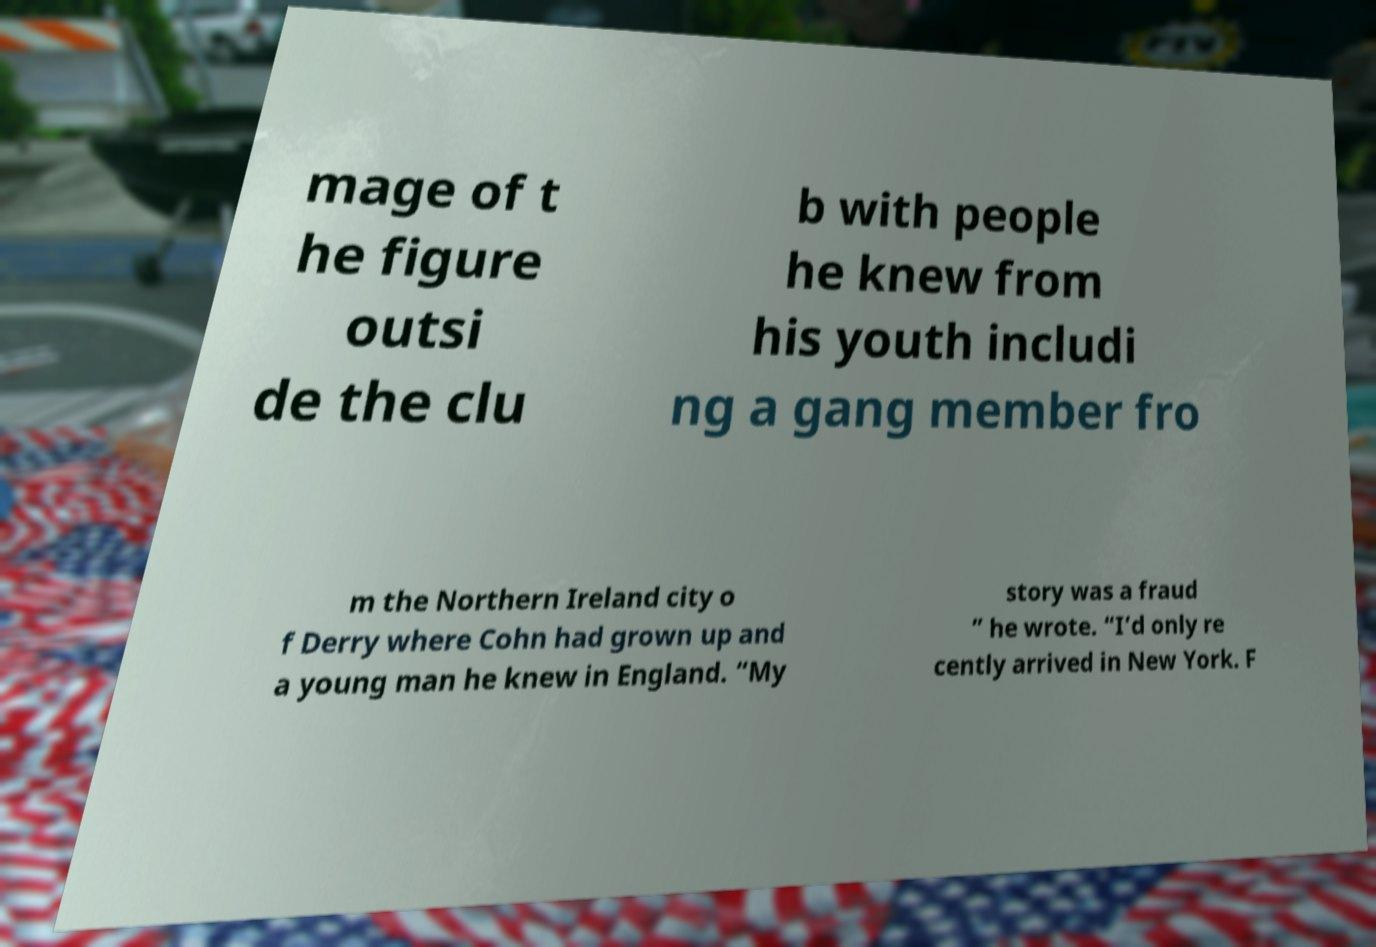What messages or text are displayed in this image? I need them in a readable, typed format. mage of t he figure outsi de the clu b with people he knew from his youth includi ng a gang member fro m the Northern Ireland city o f Derry where Cohn had grown up and a young man he knew in England. “My story was a fraud ” he wrote. “I’d only re cently arrived in New York. F 